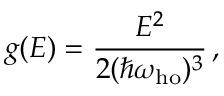Convert formula to latex. <formula><loc_0><loc_0><loc_500><loc_500>g ( E ) = { \frac { E ^ { 2 } } { 2 ( \hbar { \omega } _ { h o } ) ^ { 3 } } } \, ,</formula> 